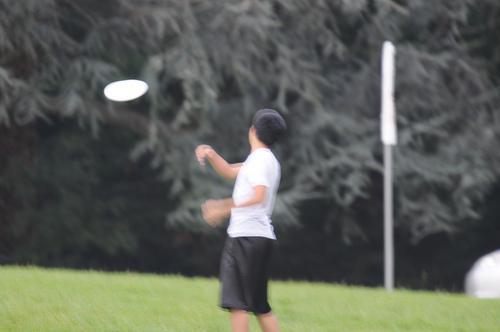Question: what is boy throwing?
Choices:
A. He is throwing a ball.
B. He is throwing a disc.
C. He is throwing a frisbee.
D. He is throwing a rock.
Answer with the letter. Answer: B Question: when was this photo taken?
Choices:
A. During the daylight.
B. Last night.
C. The first day of school.
D. Two hours ago.
Answer with the letter. Answer: A Question: what is boy looking at?
Choices:
A. His cat.
B. The boy is looking at the disc he has thrown.
C. His mother.
D. The sky.
Answer with the letter. Answer: B Question: how many people in picture?
Choices:
A. Two people.
B. Only one person.
C. Three people.
D. Zero people.
Answer with the letter. Answer: B Question: what color is the boys pants?
Choices:
A. The pants are blue.
B. The pants are red.
C. The pants are green.
D. The pants are black.
Answer with the letter. Answer: D Question: where was this picture taken?
Choices:
A. The picture was taken at school.
B. Picture was taken in a park.
C. The picture was taken at home.
D. The picture was taken at the beach.
Answer with the letter. Answer: B 